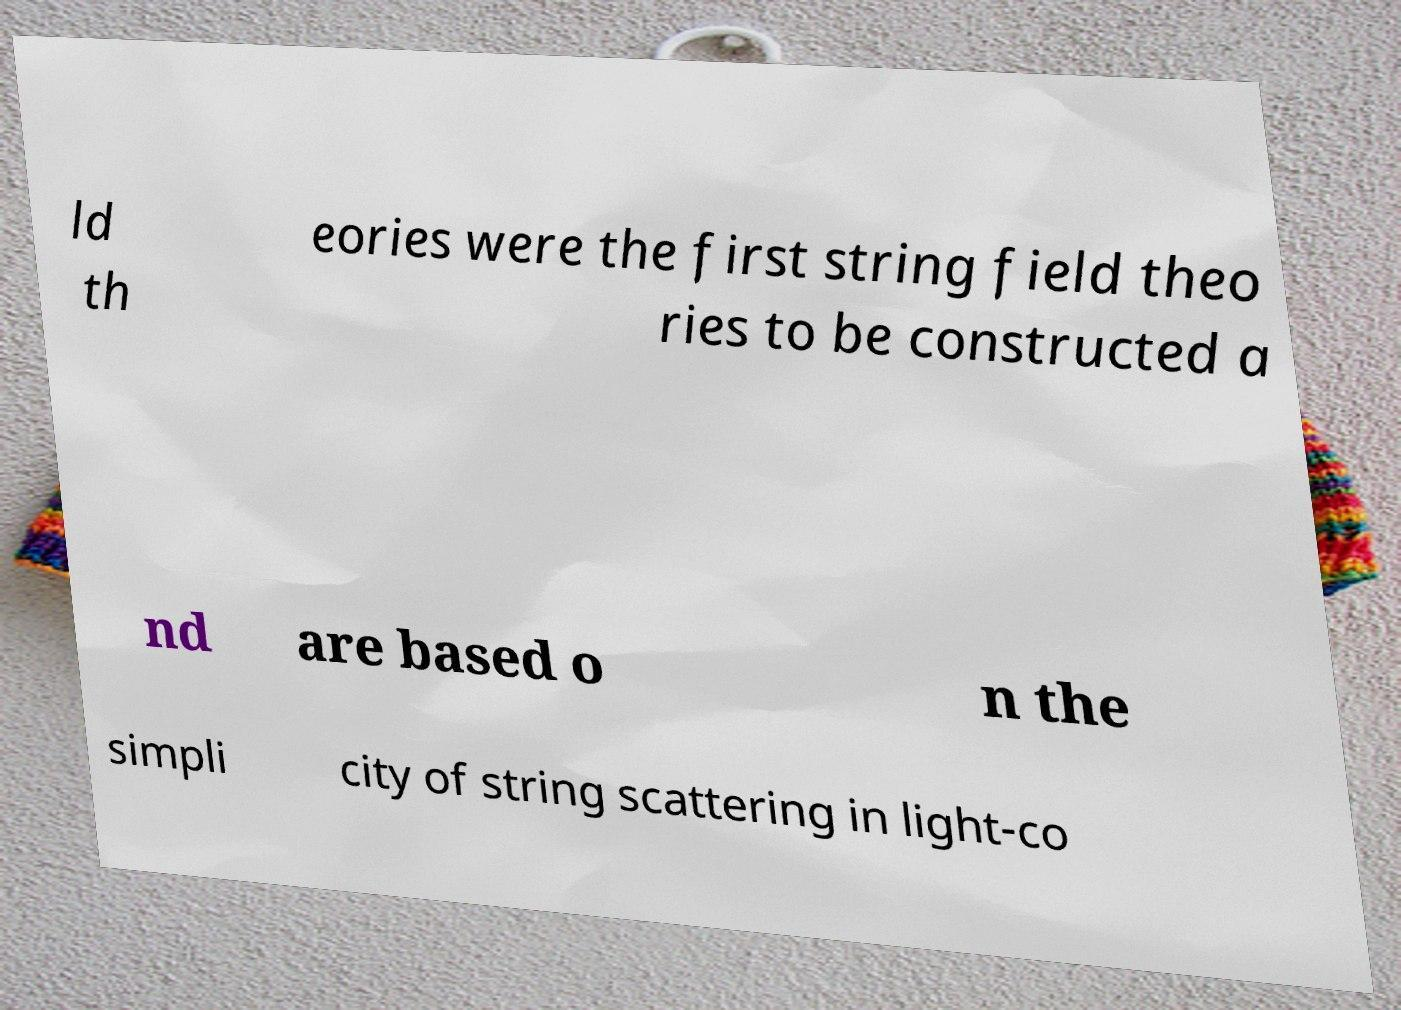Can you read and provide the text displayed in the image?This photo seems to have some interesting text. Can you extract and type it out for me? ld th eories were the first string field theo ries to be constructed a nd are based o n the simpli city of string scattering in light-co 